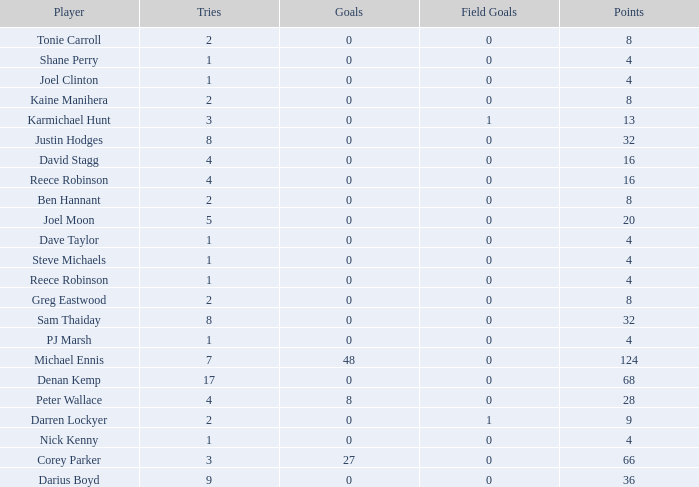How many goals did the player with less than 4 points have? 0.0. 